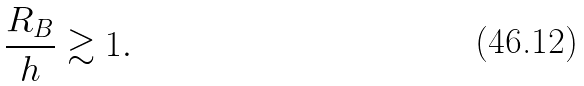<formula> <loc_0><loc_0><loc_500><loc_500>\frac { R _ { B } } { h } \gtrsim 1 .</formula> 